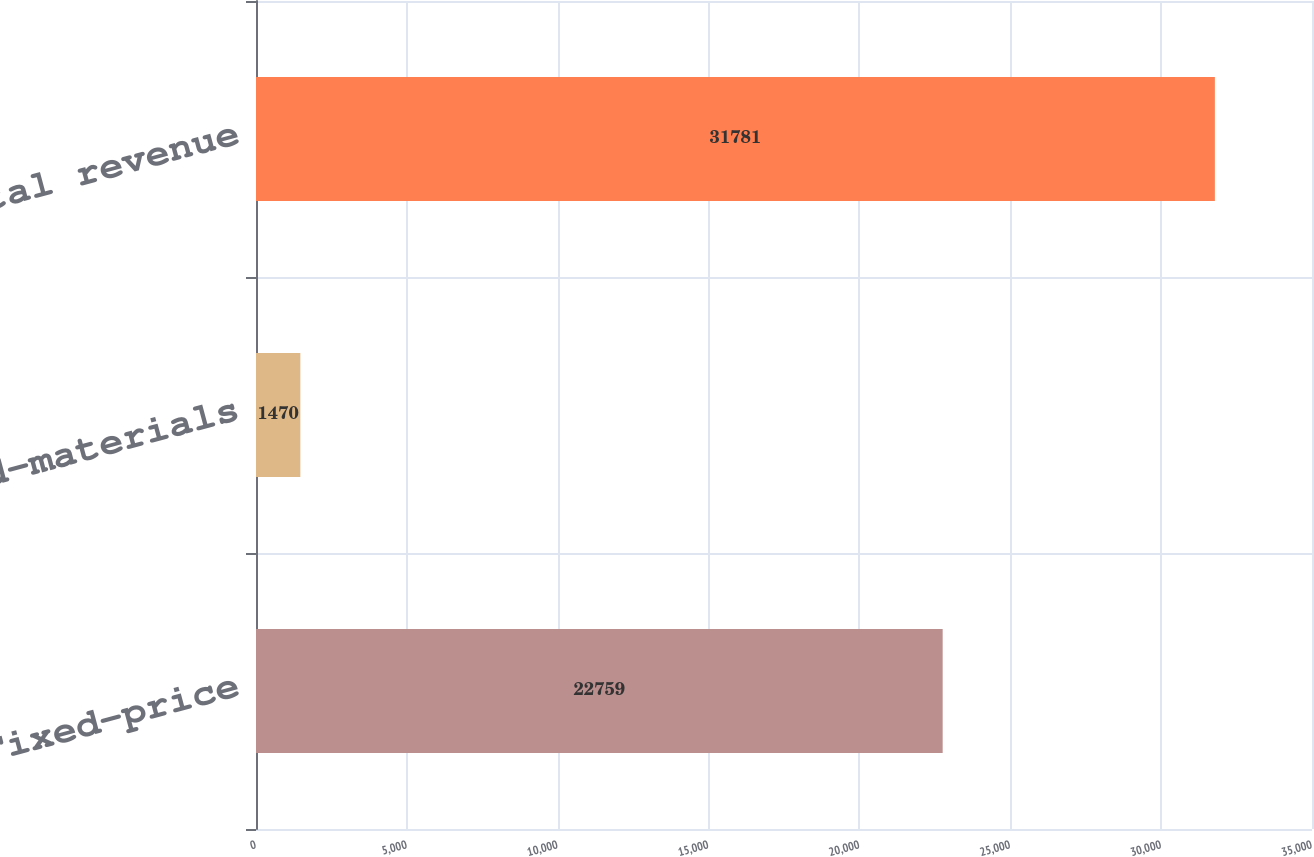Convert chart. <chart><loc_0><loc_0><loc_500><loc_500><bar_chart><fcel>Fixed-price<fcel>Time-and-materials<fcel>Total revenue<nl><fcel>22759<fcel>1470<fcel>31781<nl></chart> 